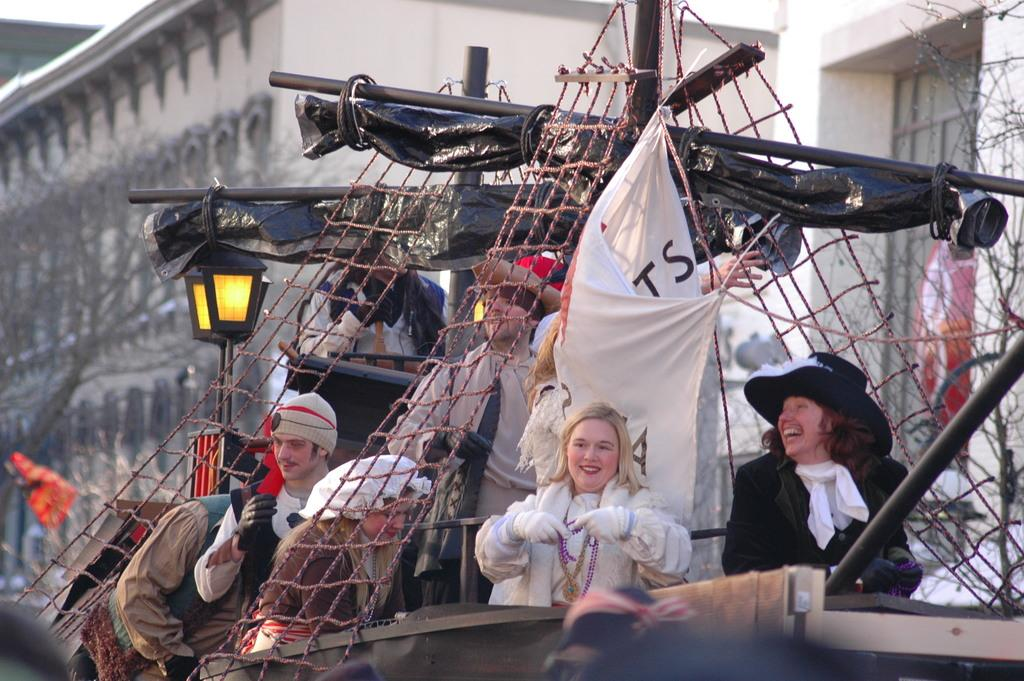What are the people in the image doing? The people in the image are standing in a vehicle. What can be seen behind the vehicle in the image? There are trees visible behind the vehicle. What else is present in the background of the image? There are poles and buildings in the background of the image. How many buns are being added to the vehicle in the image? There are no buns present in the image, and no addition of buns is taking place. 